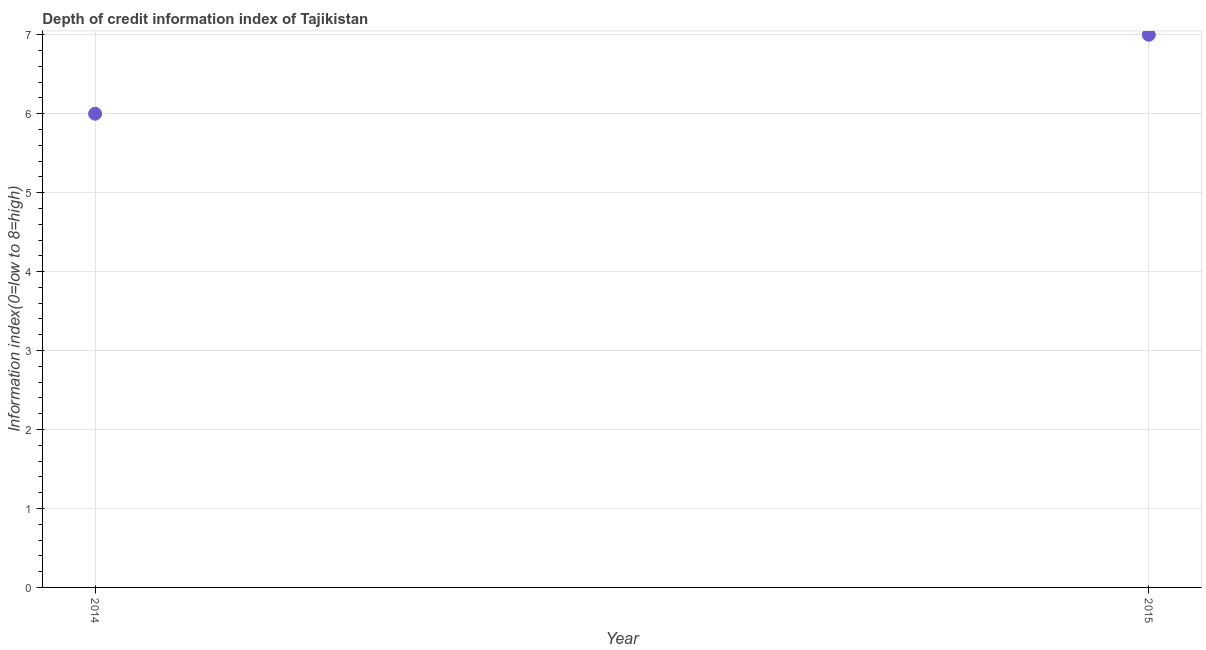What is the depth of credit information index in 2015?
Your response must be concise. 7. Across all years, what is the maximum depth of credit information index?
Give a very brief answer. 7. Across all years, what is the minimum depth of credit information index?
Provide a succinct answer. 6. In which year was the depth of credit information index maximum?
Give a very brief answer. 2015. In which year was the depth of credit information index minimum?
Make the answer very short. 2014. What is the sum of the depth of credit information index?
Offer a very short reply. 13. What is the difference between the depth of credit information index in 2014 and 2015?
Offer a very short reply. -1. What is the median depth of credit information index?
Make the answer very short. 6.5. In how many years, is the depth of credit information index greater than 0.6000000000000001 ?
Your answer should be compact. 2. Do a majority of the years between 2015 and 2014 (inclusive) have depth of credit information index greater than 0.6000000000000001 ?
Make the answer very short. No. What is the ratio of the depth of credit information index in 2014 to that in 2015?
Keep it short and to the point. 0.86. Is the depth of credit information index in 2014 less than that in 2015?
Your answer should be very brief. Yes. In how many years, is the depth of credit information index greater than the average depth of credit information index taken over all years?
Provide a short and direct response. 1. Does the depth of credit information index monotonically increase over the years?
Offer a terse response. Yes. Are the values on the major ticks of Y-axis written in scientific E-notation?
Ensure brevity in your answer.  No. Does the graph contain any zero values?
Your answer should be compact. No. Does the graph contain grids?
Your answer should be very brief. Yes. What is the title of the graph?
Keep it short and to the point. Depth of credit information index of Tajikistan. What is the label or title of the X-axis?
Provide a short and direct response. Year. What is the label or title of the Y-axis?
Make the answer very short. Information index(0=low to 8=high). What is the Information index(0=low to 8=high) in 2015?
Offer a terse response. 7. What is the ratio of the Information index(0=low to 8=high) in 2014 to that in 2015?
Your response must be concise. 0.86. 